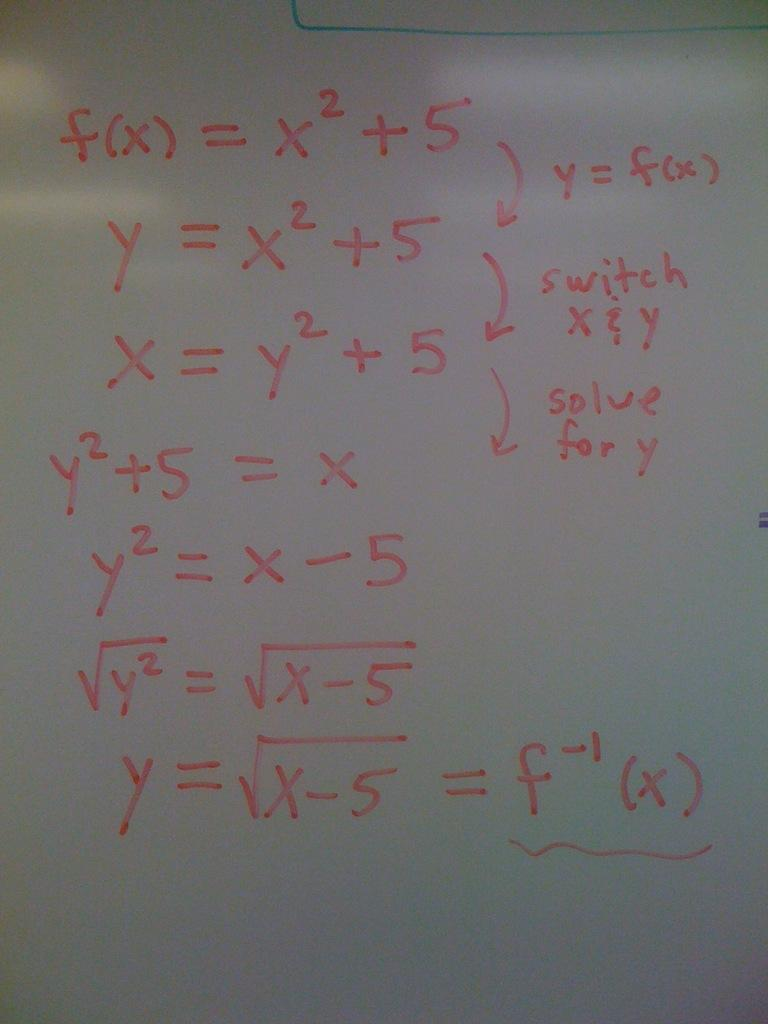<image>
Create a compact narrative representing the image presented. A long math equation starts with f(x) = x2 + 5 